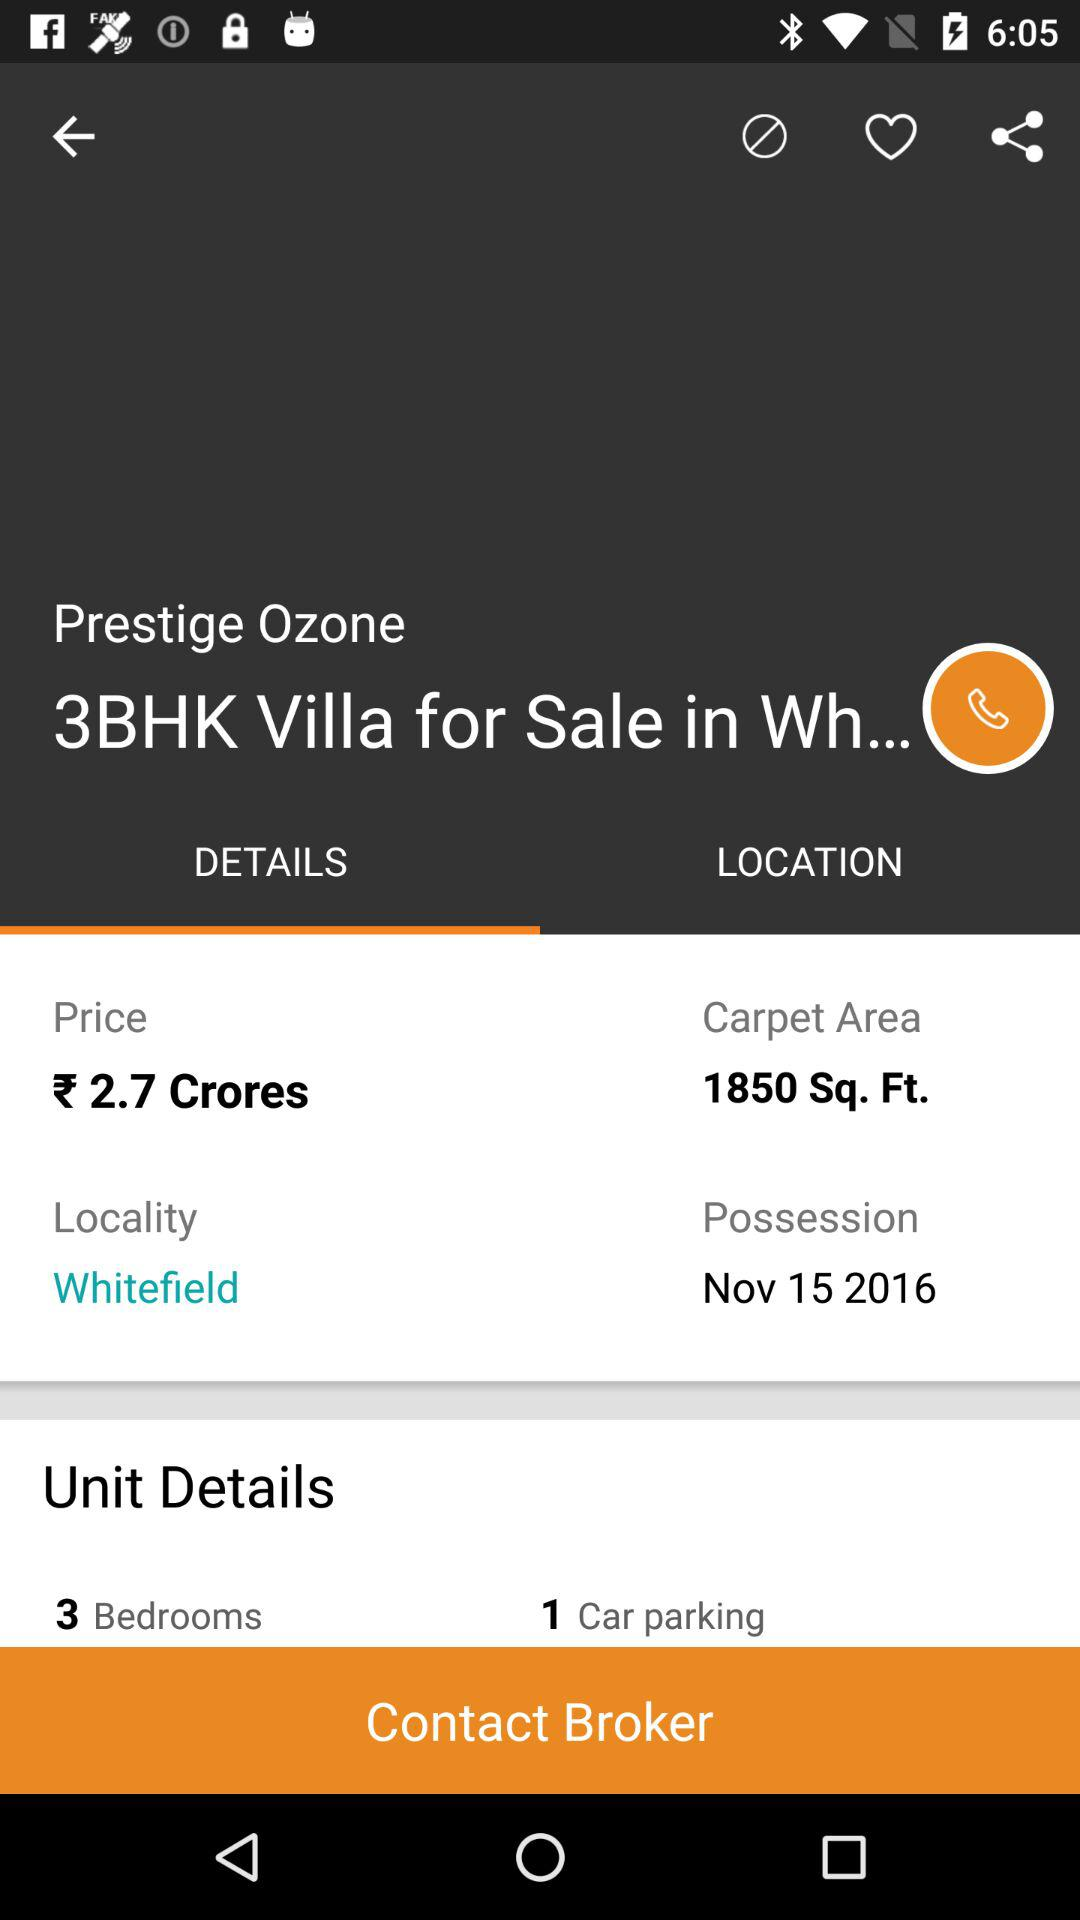What is the price of this property?
Answer the question using a single word or phrase. 2.7 Crores 